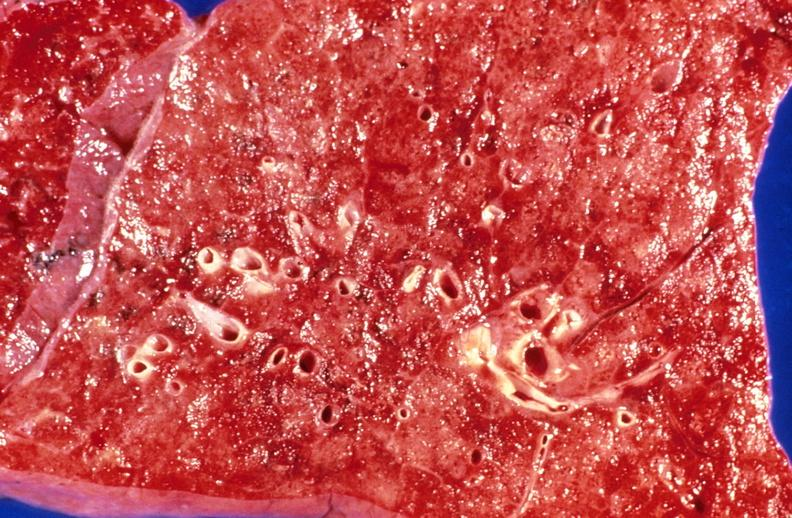where is this?
Answer the question using a single word or phrase. Lung 